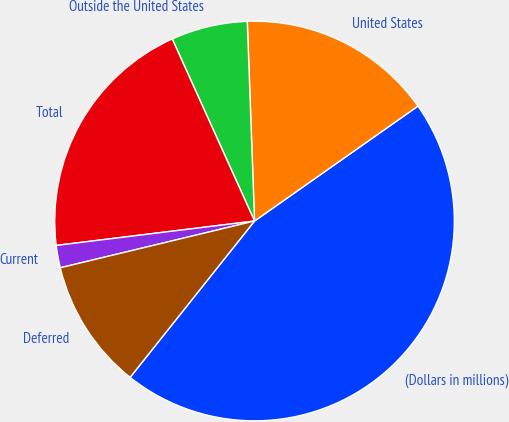Convert chart. <chart><loc_0><loc_0><loc_500><loc_500><pie_chart><fcel>(Dollars in millions)<fcel>United States<fcel>Outside the United States<fcel>Total<fcel>Current<fcel>Deferred<nl><fcel>45.45%<fcel>15.82%<fcel>6.18%<fcel>20.19%<fcel>1.81%<fcel>10.54%<nl></chart> 